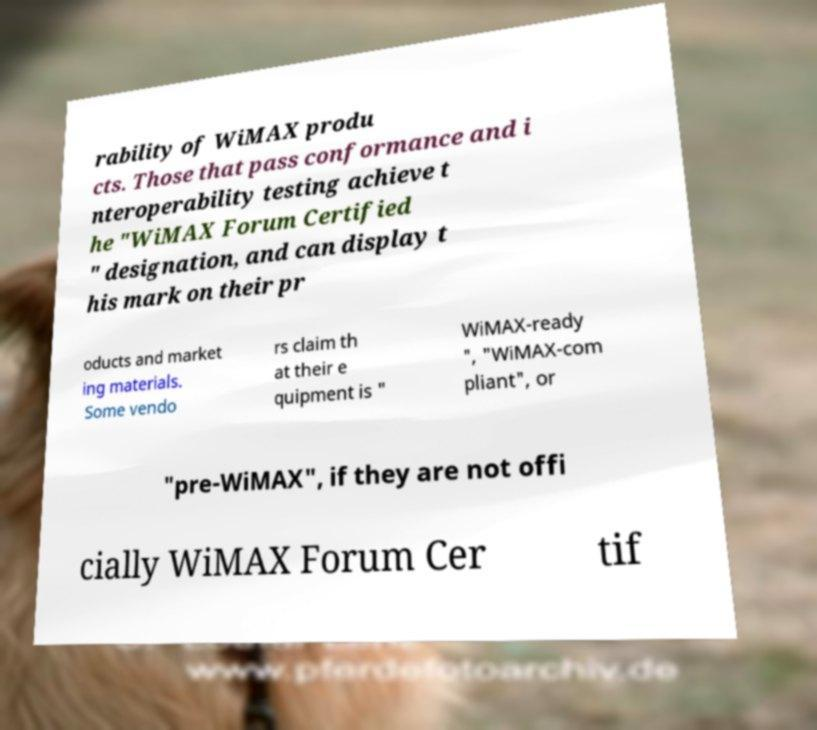There's text embedded in this image that I need extracted. Can you transcribe it verbatim? rability of WiMAX produ cts. Those that pass conformance and i nteroperability testing achieve t he "WiMAX Forum Certified " designation, and can display t his mark on their pr oducts and market ing materials. Some vendo rs claim th at their e quipment is " WiMAX-ready ", "WiMAX-com pliant", or "pre-WiMAX", if they are not offi cially WiMAX Forum Cer tif 